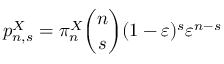Convert formula to latex. <formula><loc_0><loc_0><loc_500><loc_500>p _ { n , s } ^ { X } = \pi _ { n } ^ { X } \binom { n } { s } ( 1 - \varepsilon ) ^ { s } \varepsilon ^ { n - s }</formula> 